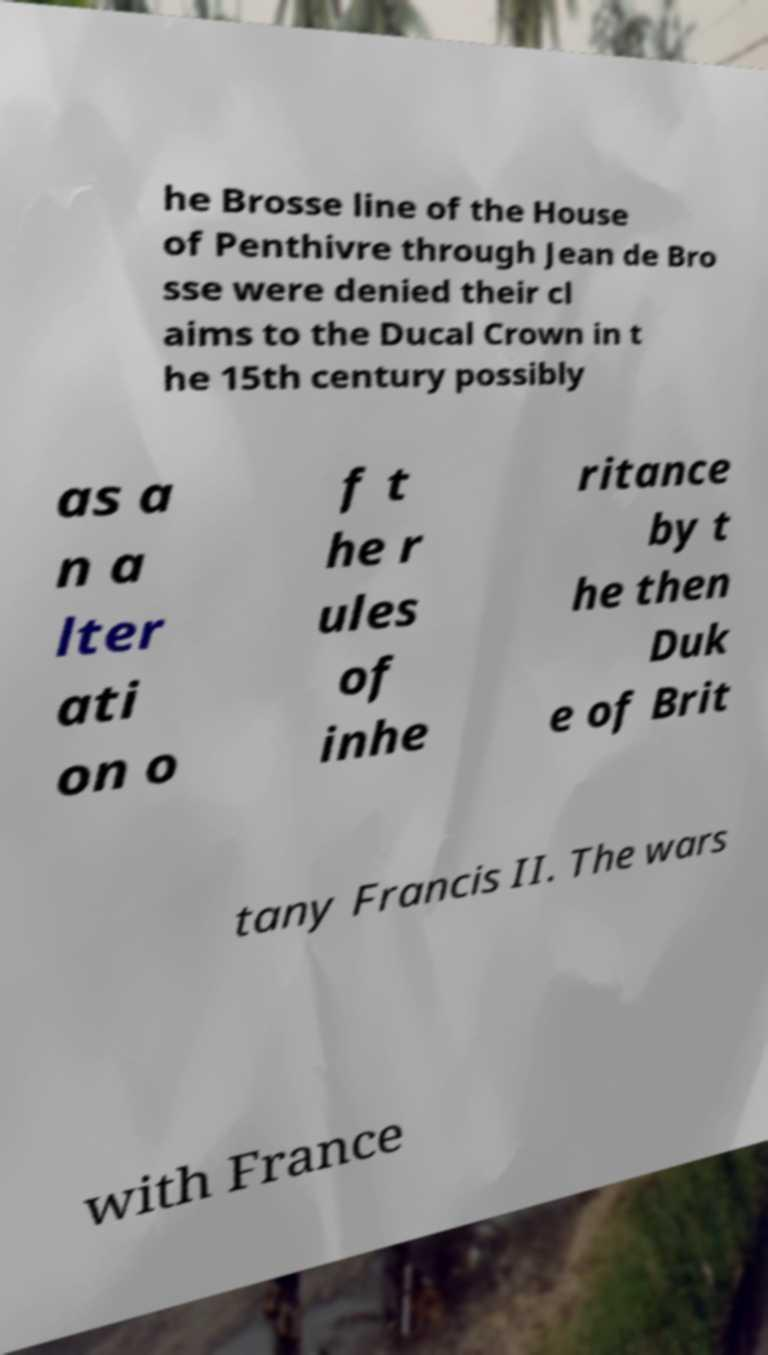Please read and relay the text visible in this image. What does it say? he Brosse line of the House of Penthivre through Jean de Bro sse were denied their cl aims to the Ducal Crown in t he 15th century possibly as a n a lter ati on o f t he r ules of inhe ritance by t he then Duk e of Brit tany Francis II. The wars with France 